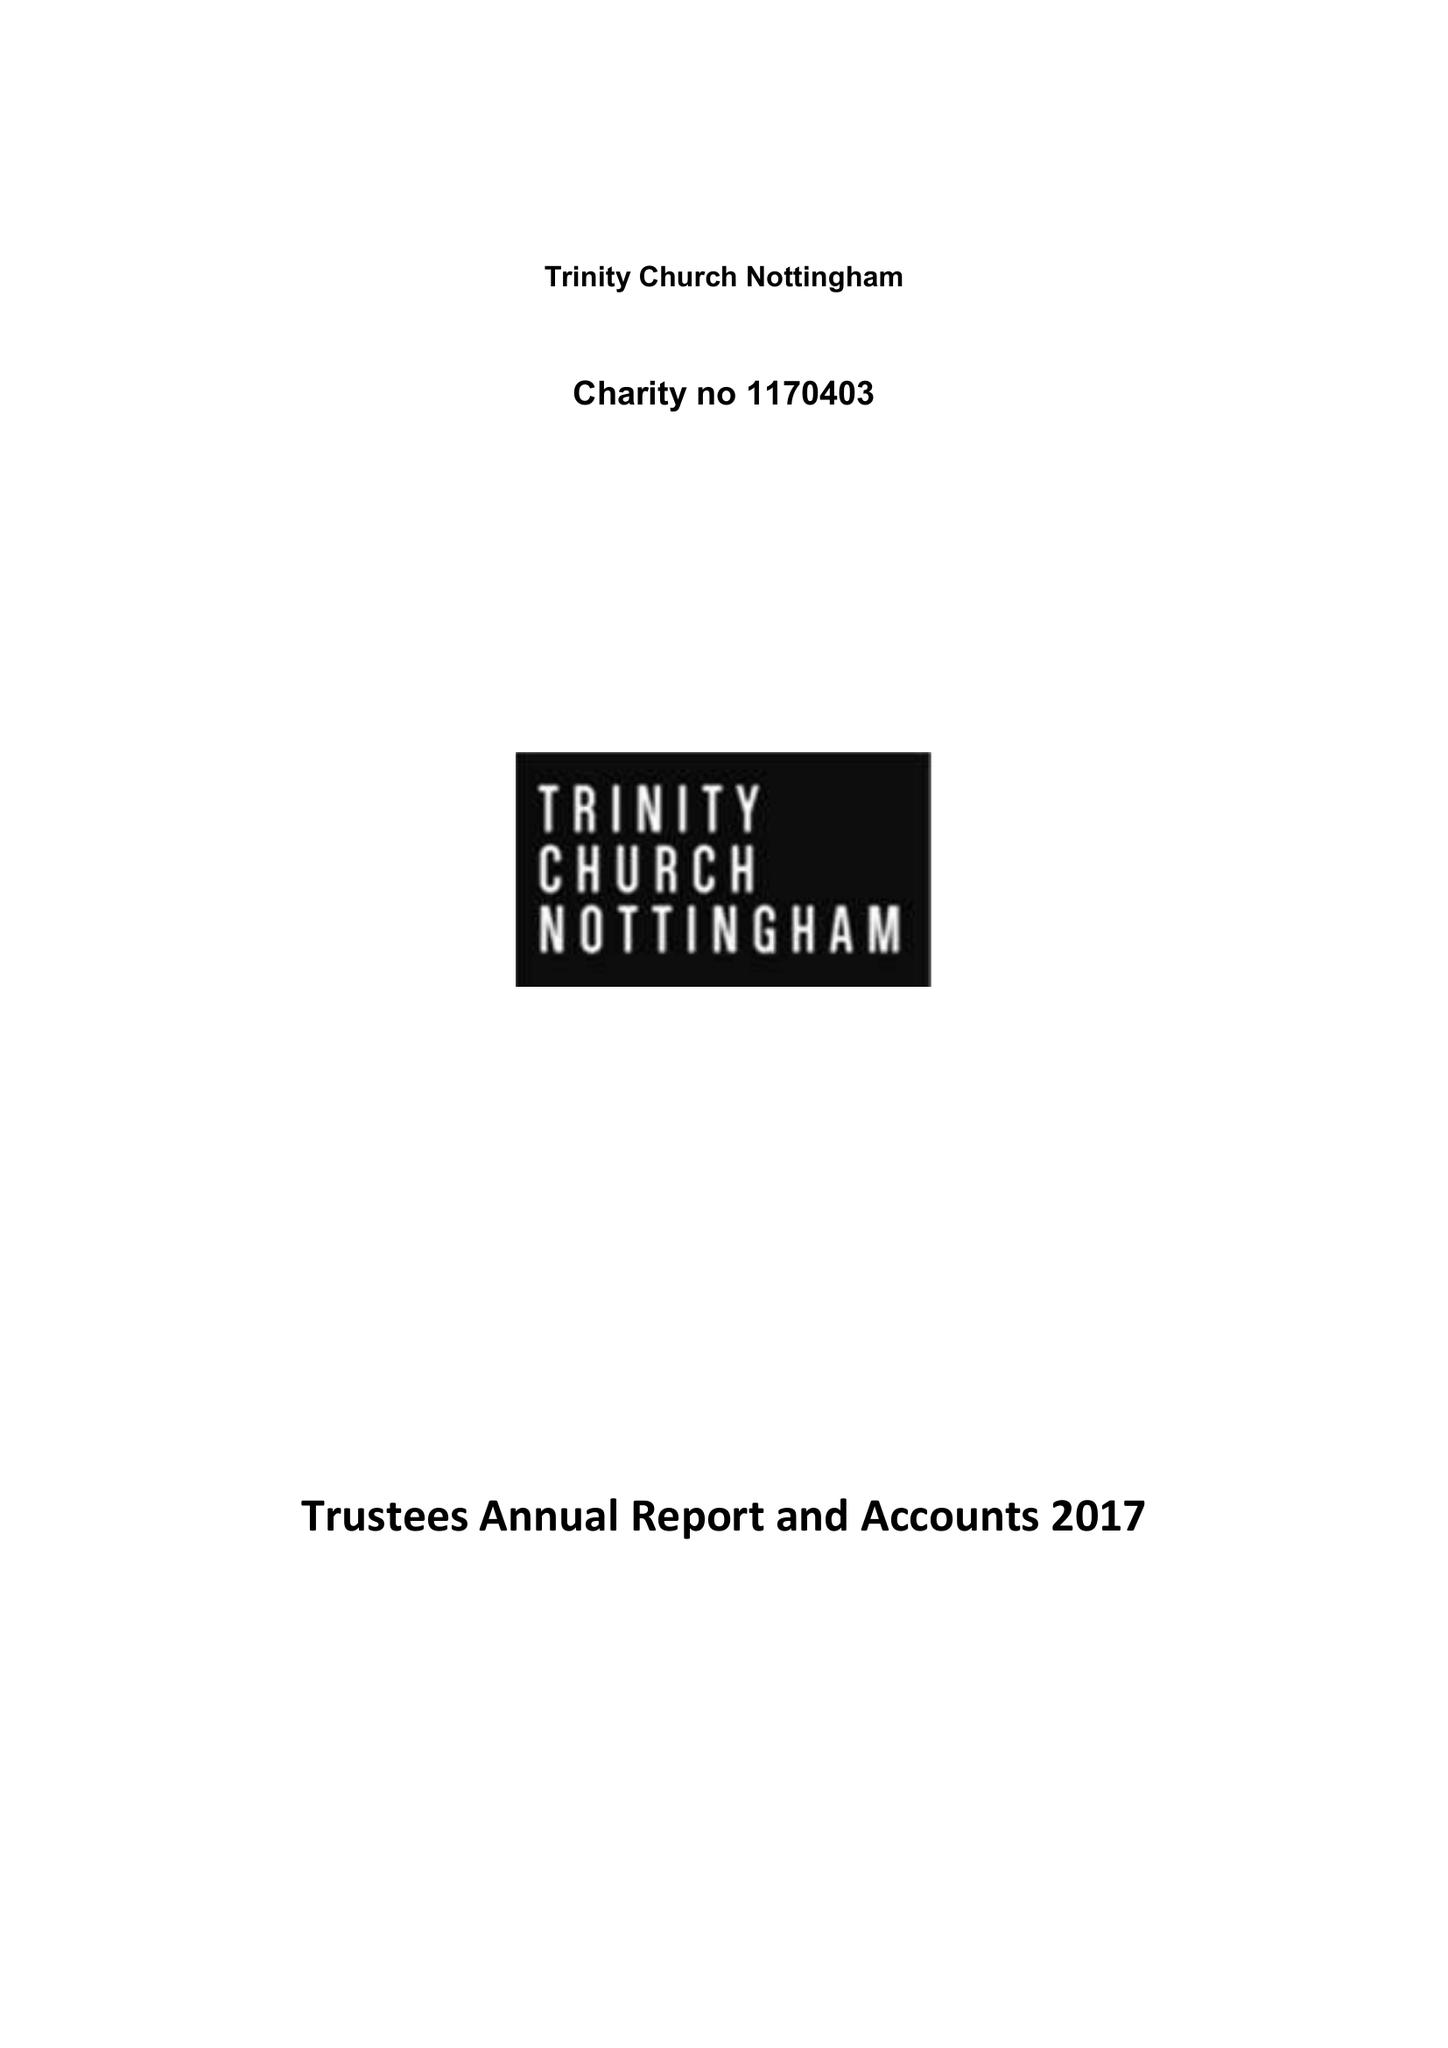What is the value for the charity_number?
Answer the question using a single word or phrase. 1170403 